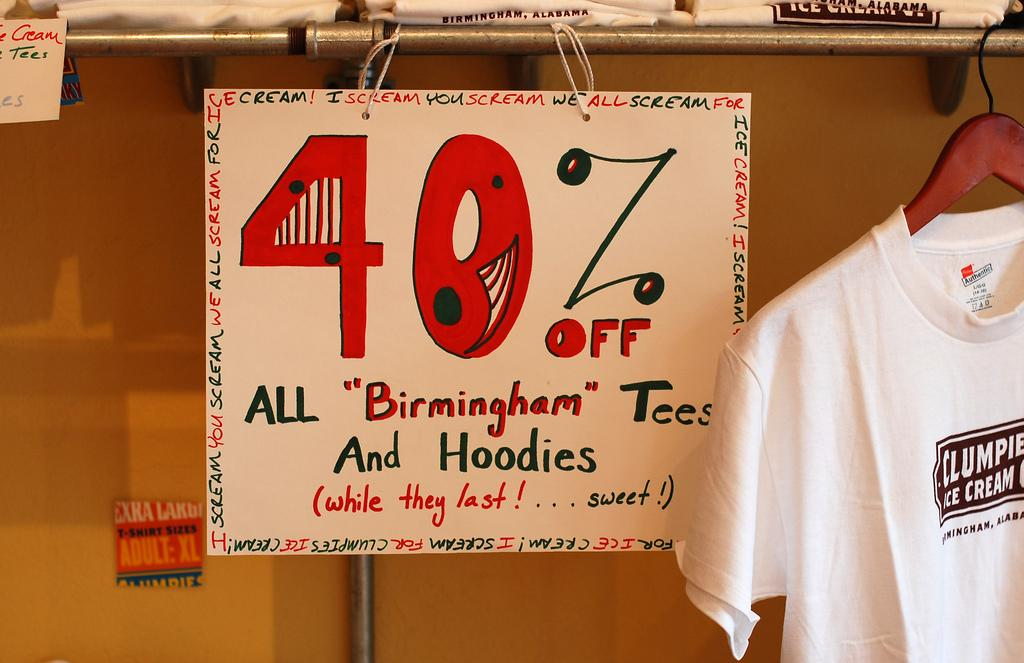What type of clothing items are visible on the shelf in the image? There are t-shirts on a shelf in the image. Can you describe another way t-shirts are displayed in the image? There is a t-shirt on a hanger in the image. What else can be seen hanging from a rod in the image? There is a placard hanging from a rod in the image. What grade is the oatmeal being served in the image? There is no oatmeal present in the image, so it is not possible to determine the grade being served. 